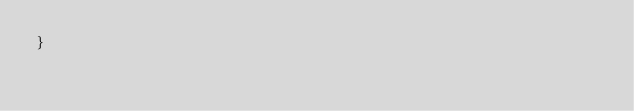<code> <loc_0><loc_0><loc_500><loc_500><_Rust_>}
</code> 